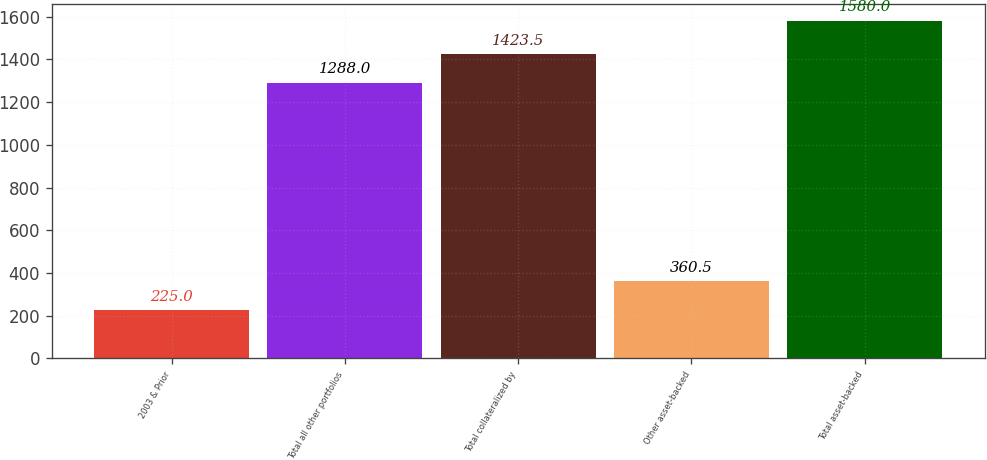Convert chart to OTSL. <chart><loc_0><loc_0><loc_500><loc_500><bar_chart><fcel>2003 & Prior<fcel>Total all other portfolios<fcel>Total collateralized by<fcel>Other asset-backed<fcel>Total asset-backed<nl><fcel>225<fcel>1288<fcel>1423.5<fcel>360.5<fcel>1580<nl></chart> 